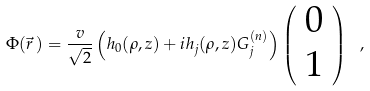<formula> <loc_0><loc_0><loc_500><loc_500>\Phi ( \vec { r } \, ) = \frac { v } { \sqrt { 2 } } \left ( h _ { 0 } ( \rho , z ) + i h _ { j } ( \rho , z ) G _ { j } ^ { ( n ) } \right ) \left ( \begin{array} { c } 0 \\ 1 \end{array} \right ) \ ,</formula> 